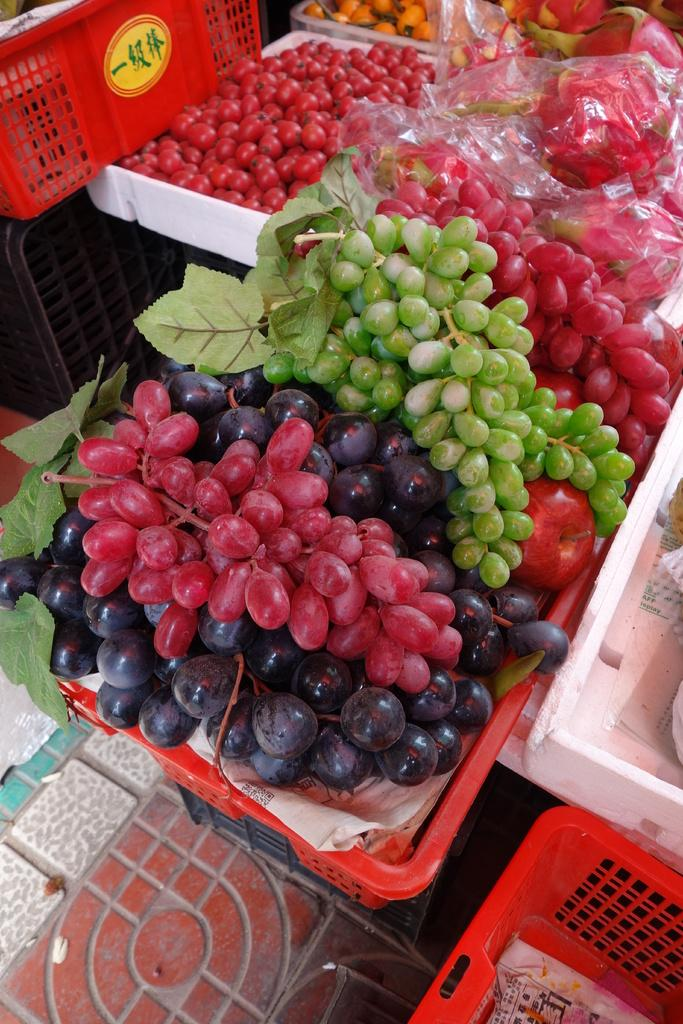What types of food items can be seen in the image? There are different kinds of fruits and vegetables in the image. How are the fruits and vegetables organized in the image? The fruits and vegetables are arranged in plastic cartons and polythene covers. Can you tell me how many knives are used to cut the fruits and vegetables in the image? There are no knives visible in the image; the fruits and vegetables are arranged in plastic cartons and polythene covers. What type of bean is present in the image? There is no bean present in the image; it features different kinds of fruits and vegetables. 